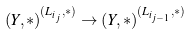<formula> <loc_0><loc_0><loc_500><loc_500>( Y , * ) ^ { ( L _ { i _ { j } } , * ) } \to ( Y , * ) ^ { ( L _ { i _ { j - 1 } } , * ) }</formula> 